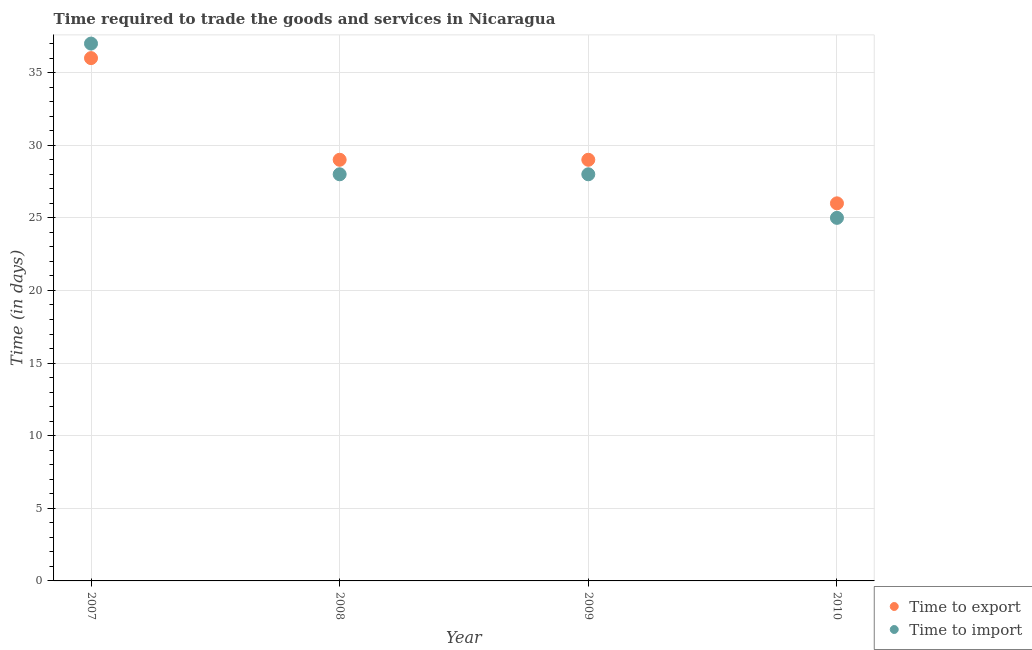What is the time to import in 2008?
Provide a succinct answer. 28. Across all years, what is the maximum time to export?
Offer a terse response. 36. Across all years, what is the minimum time to import?
Offer a terse response. 25. What is the total time to import in the graph?
Provide a succinct answer. 118. What is the difference between the time to export in 2008 and that in 2010?
Ensure brevity in your answer.  3. What is the difference between the time to export in 2009 and the time to import in 2008?
Your answer should be very brief. 1. What is the average time to export per year?
Make the answer very short. 30. In the year 2010, what is the difference between the time to import and time to export?
Your answer should be very brief. -1. What is the ratio of the time to import in 2007 to that in 2008?
Offer a very short reply. 1.32. Is the difference between the time to export in 2007 and 2010 greater than the difference between the time to import in 2007 and 2010?
Your answer should be very brief. No. What is the difference between the highest and the second highest time to export?
Ensure brevity in your answer.  7. What is the difference between the highest and the lowest time to import?
Your answer should be compact. 12. In how many years, is the time to export greater than the average time to export taken over all years?
Provide a short and direct response. 1. Is the sum of the time to import in 2007 and 2009 greater than the maximum time to export across all years?
Your response must be concise. Yes. Is the time to import strictly less than the time to export over the years?
Provide a short and direct response. No. How many years are there in the graph?
Offer a very short reply. 4. What is the difference between two consecutive major ticks on the Y-axis?
Your answer should be compact. 5. Does the graph contain any zero values?
Keep it short and to the point. No. Does the graph contain grids?
Ensure brevity in your answer.  Yes. Where does the legend appear in the graph?
Provide a short and direct response. Bottom right. What is the title of the graph?
Your answer should be very brief. Time required to trade the goods and services in Nicaragua. Does "Personal remittances" appear as one of the legend labels in the graph?
Make the answer very short. No. What is the label or title of the X-axis?
Provide a succinct answer. Year. What is the label or title of the Y-axis?
Offer a terse response. Time (in days). What is the Time (in days) of Time to export in 2007?
Offer a terse response. 36. What is the Time (in days) of Time to export in 2008?
Provide a short and direct response. 29. What is the Time (in days) of Time to export in 2009?
Provide a succinct answer. 29. What is the Time (in days) of Time to import in 2009?
Offer a very short reply. 28. What is the total Time (in days) of Time to export in the graph?
Offer a very short reply. 120. What is the total Time (in days) of Time to import in the graph?
Keep it short and to the point. 118. What is the difference between the Time (in days) in Time to export in 2007 and that in 2008?
Offer a terse response. 7. What is the difference between the Time (in days) in Time to export in 2007 and that in 2009?
Your answer should be very brief. 7. What is the difference between the Time (in days) in Time to import in 2007 and that in 2010?
Offer a terse response. 12. What is the difference between the Time (in days) of Time to import in 2008 and that in 2009?
Offer a terse response. 0. What is the difference between the Time (in days) of Time to export in 2008 and that in 2010?
Your response must be concise. 3. What is the difference between the Time (in days) in Time to import in 2008 and that in 2010?
Offer a terse response. 3. What is the difference between the Time (in days) in Time to import in 2009 and that in 2010?
Your answer should be very brief. 3. What is the difference between the Time (in days) of Time to export in 2007 and the Time (in days) of Time to import in 2008?
Your response must be concise. 8. What is the difference between the Time (in days) of Time to export in 2007 and the Time (in days) of Time to import in 2009?
Your answer should be compact. 8. What is the difference between the Time (in days) of Time to export in 2007 and the Time (in days) of Time to import in 2010?
Your answer should be compact. 11. What is the average Time (in days) in Time to import per year?
Give a very brief answer. 29.5. In the year 2007, what is the difference between the Time (in days) of Time to export and Time (in days) of Time to import?
Your response must be concise. -1. What is the ratio of the Time (in days) of Time to export in 2007 to that in 2008?
Give a very brief answer. 1.24. What is the ratio of the Time (in days) of Time to import in 2007 to that in 2008?
Provide a short and direct response. 1.32. What is the ratio of the Time (in days) in Time to export in 2007 to that in 2009?
Keep it short and to the point. 1.24. What is the ratio of the Time (in days) in Time to import in 2007 to that in 2009?
Your response must be concise. 1.32. What is the ratio of the Time (in days) of Time to export in 2007 to that in 2010?
Provide a succinct answer. 1.38. What is the ratio of the Time (in days) in Time to import in 2007 to that in 2010?
Ensure brevity in your answer.  1.48. What is the ratio of the Time (in days) in Time to export in 2008 to that in 2009?
Keep it short and to the point. 1. What is the ratio of the Time (in days) of Time to export in 2008 to that in 2010?
Your answer should be very brief. 1.12. What is the ratio of the Time (in days) of Time to import in 2008 to that in 2010?
Give a very brief answer. 1.12. What is the ratio of the Time (in days) of Time to export in 2009 to that in 2010?
Keep it short and to the point. 1.12. What is the ratio of the Time (in days) of Time to import in 2009 to that in 2010?
Your answer should be very brief. 1.12. What is the difference between the highest and the second highest Time (in days) in Time to export?
Provide a succinct answer. 7. What is the difference between the highest and the lowest Time (in days) of Time to export?
Offer a terse response. 10. What is the difference between the highest and the lowest Time (in days) in Time to import?
Make the answer very short. 12. 